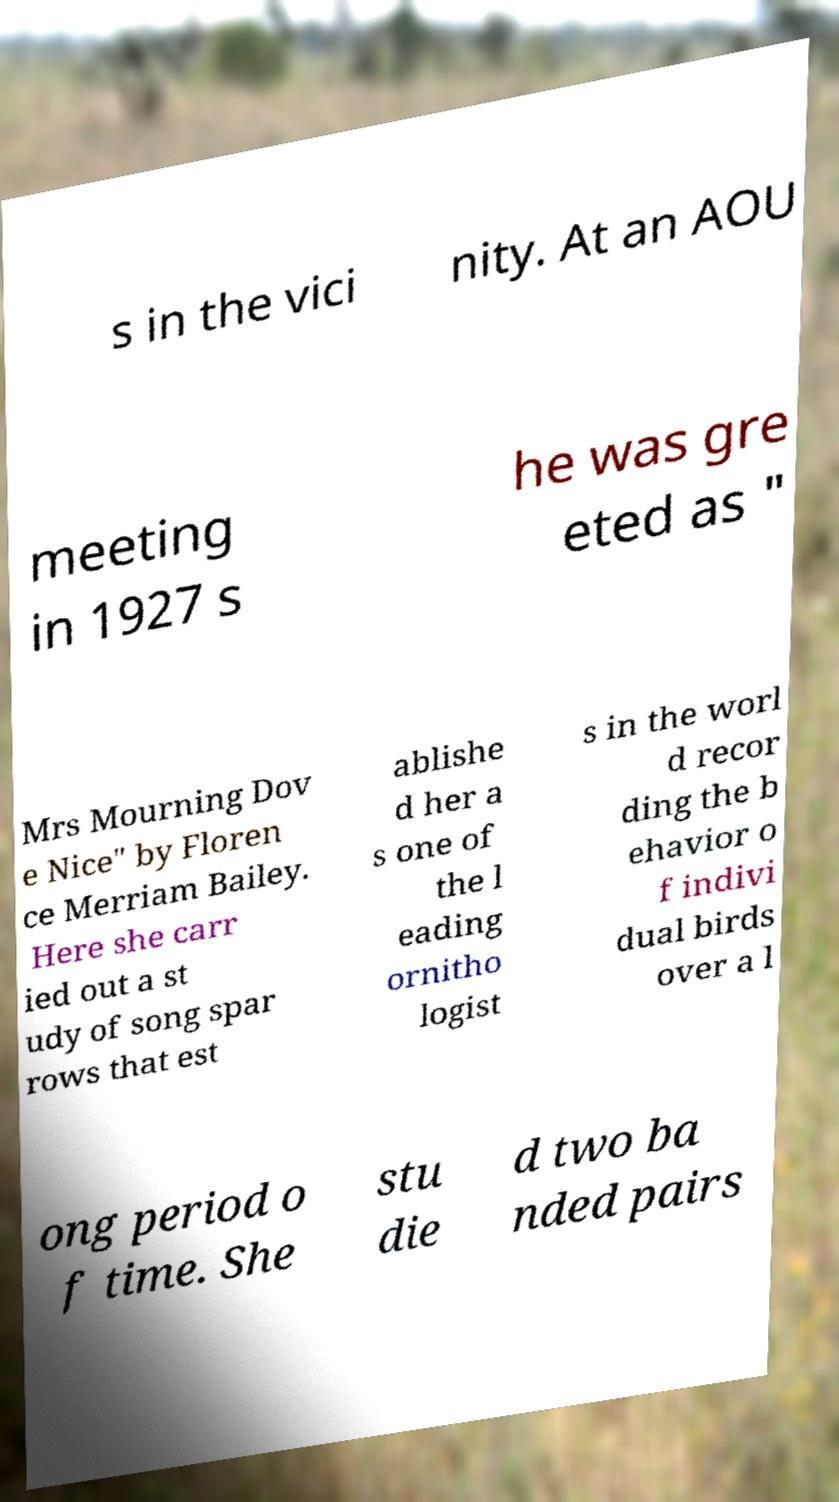I need the written content from this picture converted into text. Can you do that? s in the vici nity. At an AOU meeting in 1927 s he was gre eted as " Mrs Mourning Dov e Nice" by Floren ce Merriam Bailey. Here she carr ied out a st udy of song spar rows that est ablishe d her a s one of the l eading ornitho logist s in the worl d recor ding the b ehavior o f indivi dual birds over a l ong period o f time. She stu die d two ba nded pairs 